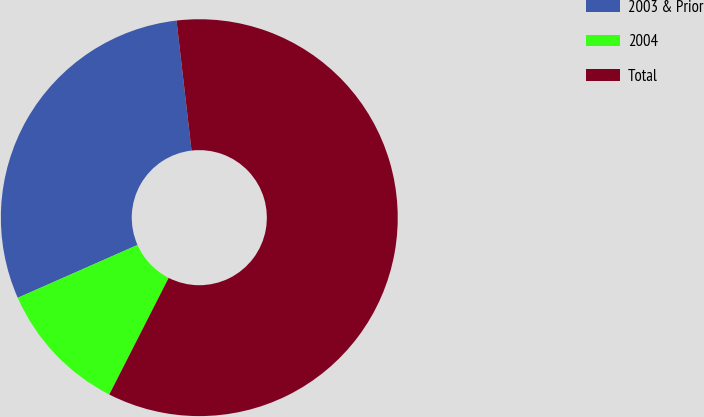Convert chart. <chart><loc_0><loc_0><loc_500><loc_500><pie_chart><fcel>2003 & Prior<fcel>2004<fcel>Total<nl><fcel>29.79%<fcel>10.89%<fcel>59.33%<nl></chart> 